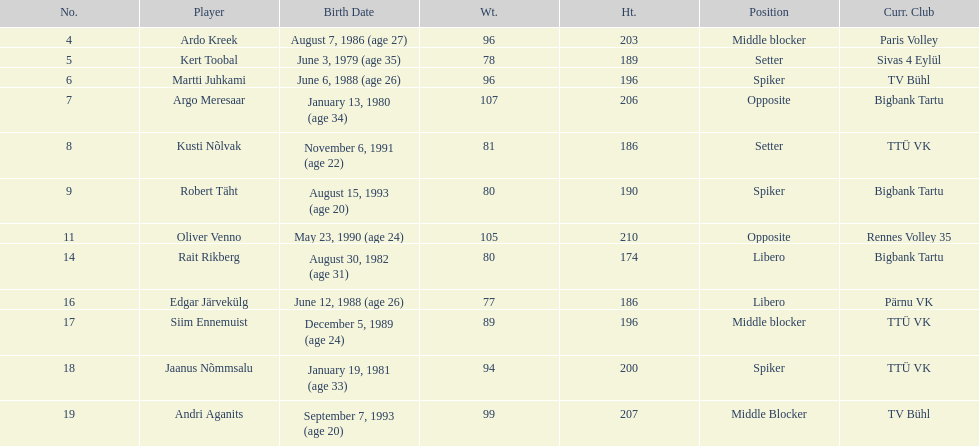How many individuals from estonia's men's national volleyball team have a birth year of 1988? 2. 